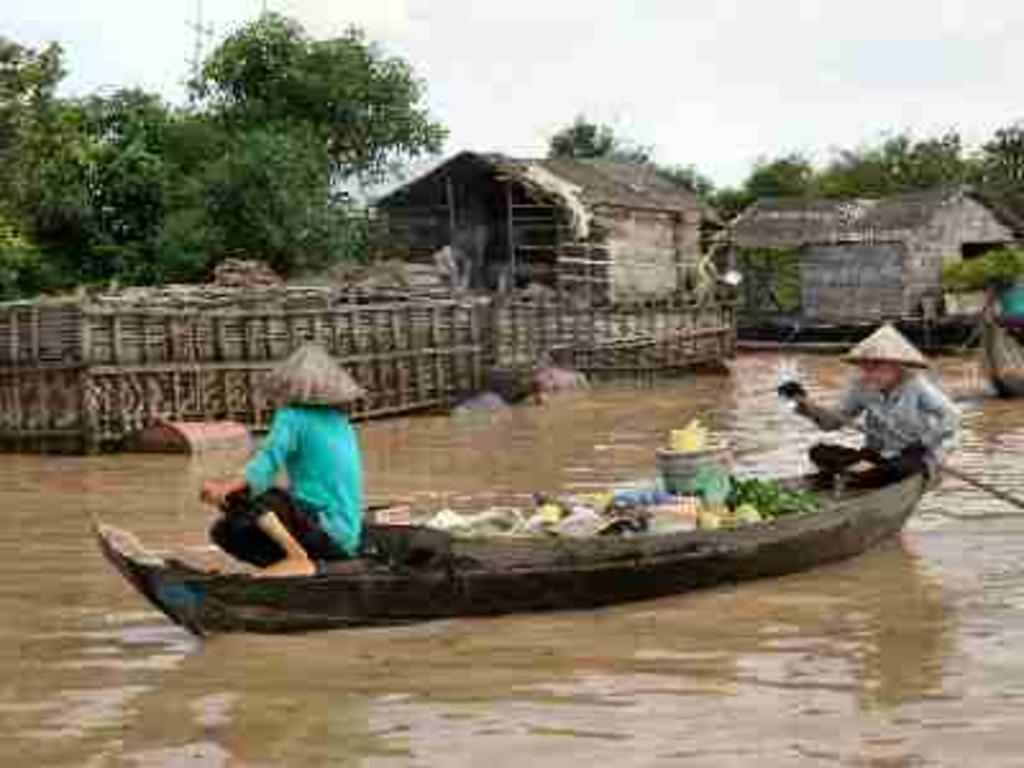How would you summarize this image in a sentence or two? In this image I can see two people sitting on the boat. These people are wearing the different color dresses. I can see few more objects on the boat. In the background I can see the houses, many trees and the sky. 